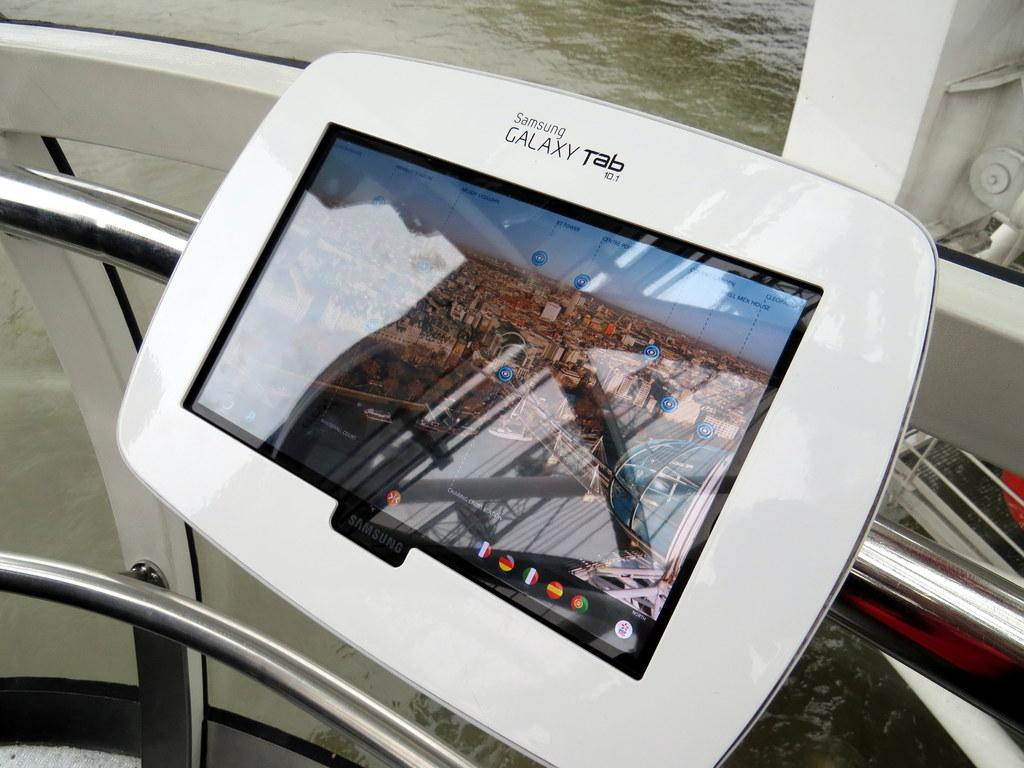What type of structure is present in the image? There is a fencing in the image. Can you describe any specific features of the fencing? Yes, there is a tab on the fencing. What can be seen behind the fencing? Water is visible behind the fencing. What type of apples are floating in the water behind the fencing? There are no apples present in the image; only water is visible behind the fencing. What type of vessel is carrying the fencing in the image? There is no vessel carrying the fencing in the image; the fencing is stationary. 